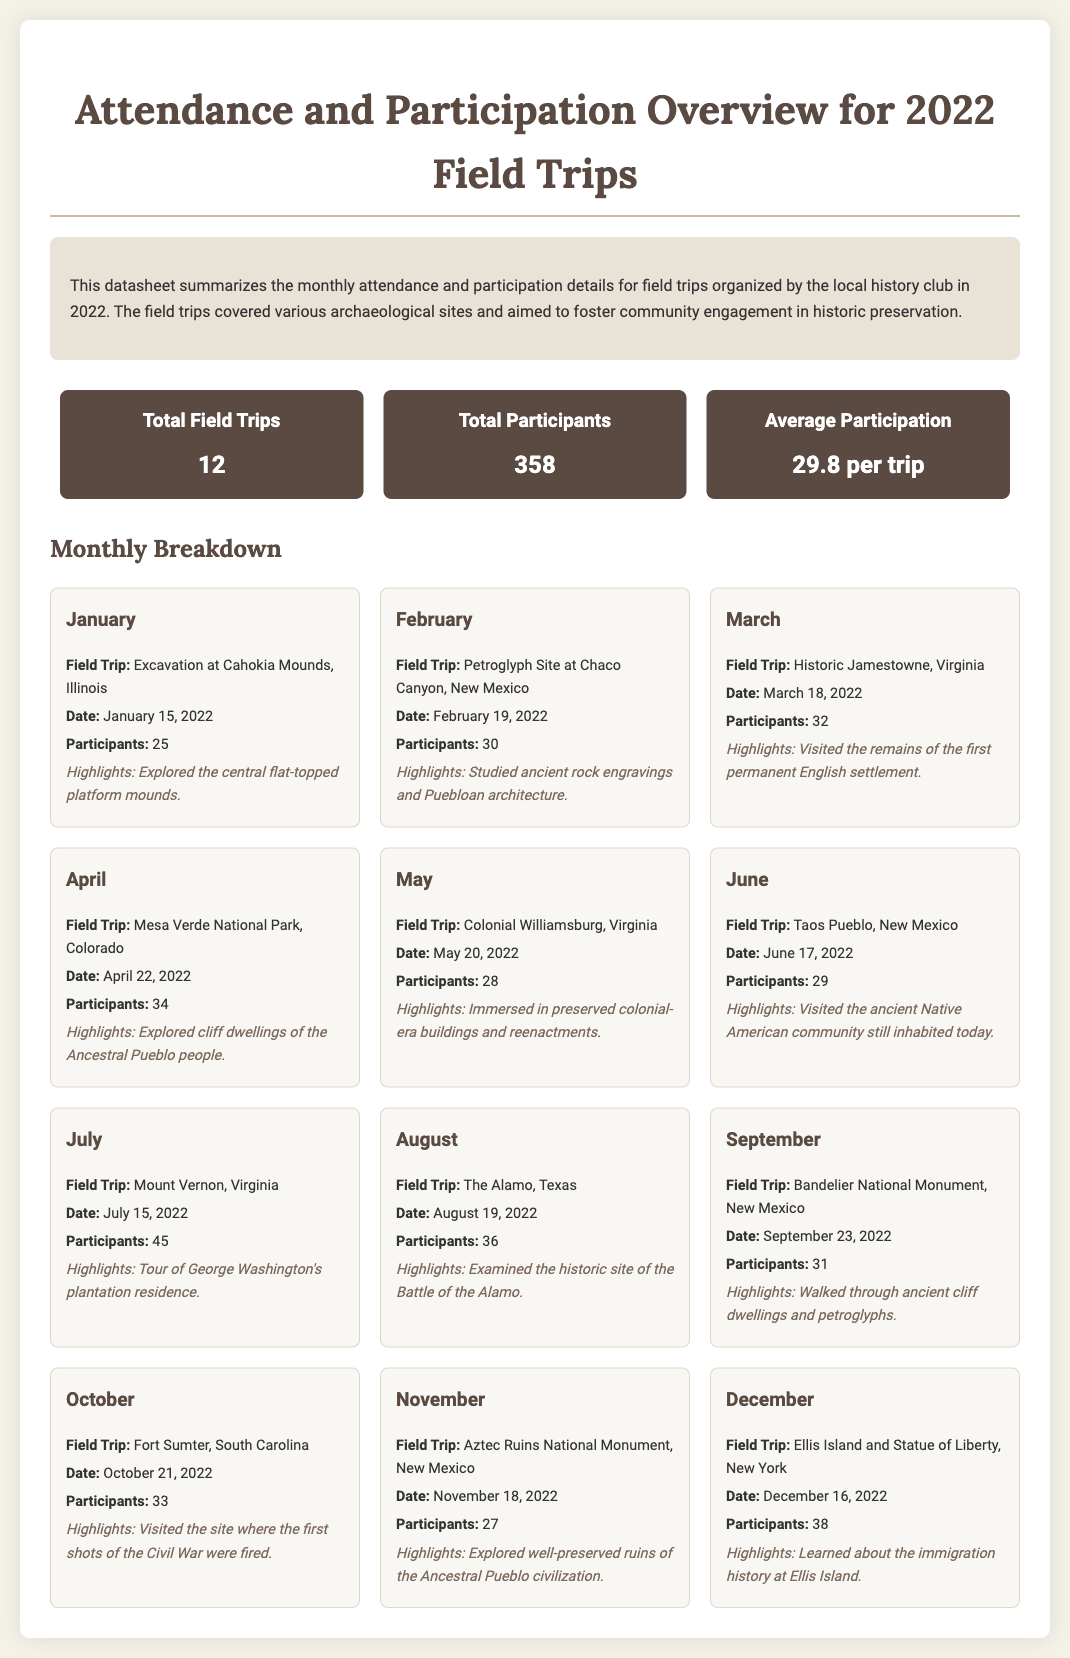What is the total number of field trips in 2022? The document states that there were a total of 12 field trips organized in 2022.
Answer: 12 What was the total number of participants? The document indicates that there were 358 participants across all field trips in 2022.
Answer: 358 What was the average participation per trip? According to the document, the average participation was 29.8 per trip.
Answer: 29.8 per trip In which month did the field trip to Mesa Verde National Park occur? The document lists that the field trip to Mesa Verde National Park took place in April.
Answer: April How many participants attended the field trip to Mount Vernon? The document shows that 45 participants attended the field trip to Mount Vernon.
Answer: 45 Which month had the highest number of participants? The document indicates that July had the highest attendance with 45 participants attending Mount Vernon.
Answer: July What archaeological site was visited in March? The document states that the field trip in March was to Historic Jamestowne.
Answer: Historic Jamestowne What was one of the highlights of the field trip to the Alamo? The document describes that one highlight was examining the historic site of the Battle of the Alamo.
Answer: Examined the historic site of the Battle of the Alamo In what year did the local history club organize these field trips? The document clearly indicates that these field trips were organized in 2022.
Answer: 2022 